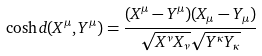Convert formula to latex. <formula><loc_0><loc_0><loc_500><loc_500>\cosh d ( X ^ { \mu } , Y ^ { \mu } ) = \frac { ( X ^ { \mu } - Y ^ { \mu } ) ( X _ { \mu } - Y _ { \mu } ) } { \sqrt { X ^ { \nu } X _ { \nu } } \sqrt { Y ^ { \kappa } Y _ { \kappa } } }</formula> 